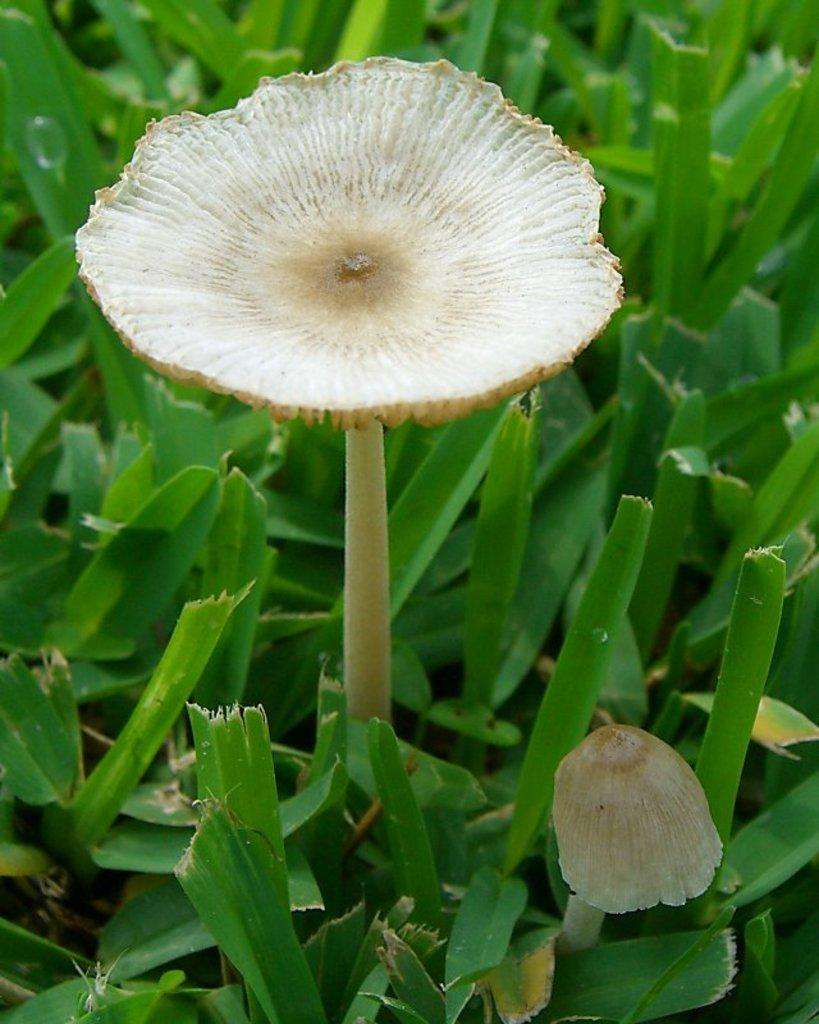What is the main subject of the image? There is a mushroom in the image. What can be seen at the bottom of the image? There are leaves at the bottom of the image. What type of muscle is visible in the image? There is no muscle visible in the image; it features a mushroom and leaves. What color is the paint used in the image? There is no paint present in the image, as it is a photograph of a mushroom and leaves. 